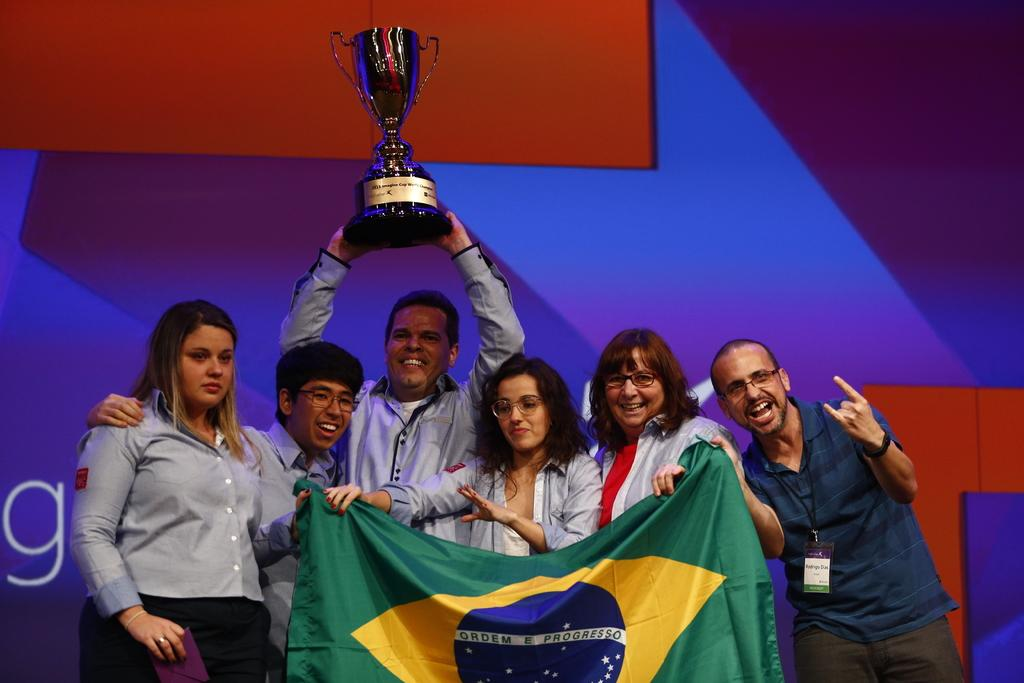What is happening in the image involving a group of people? There is a group of people in the image, and some of them are holding a flag. Can you describe any specific objects being held by the people in the image? Yes, a man is holding a trophy in the image. What type of flowers are being presented to the group in the image? There are no flowers present in the image. What time of day is it in the image, given the presence of morning light? The time of day is not mentioned or indicated in the image, so it cannot be determined. 